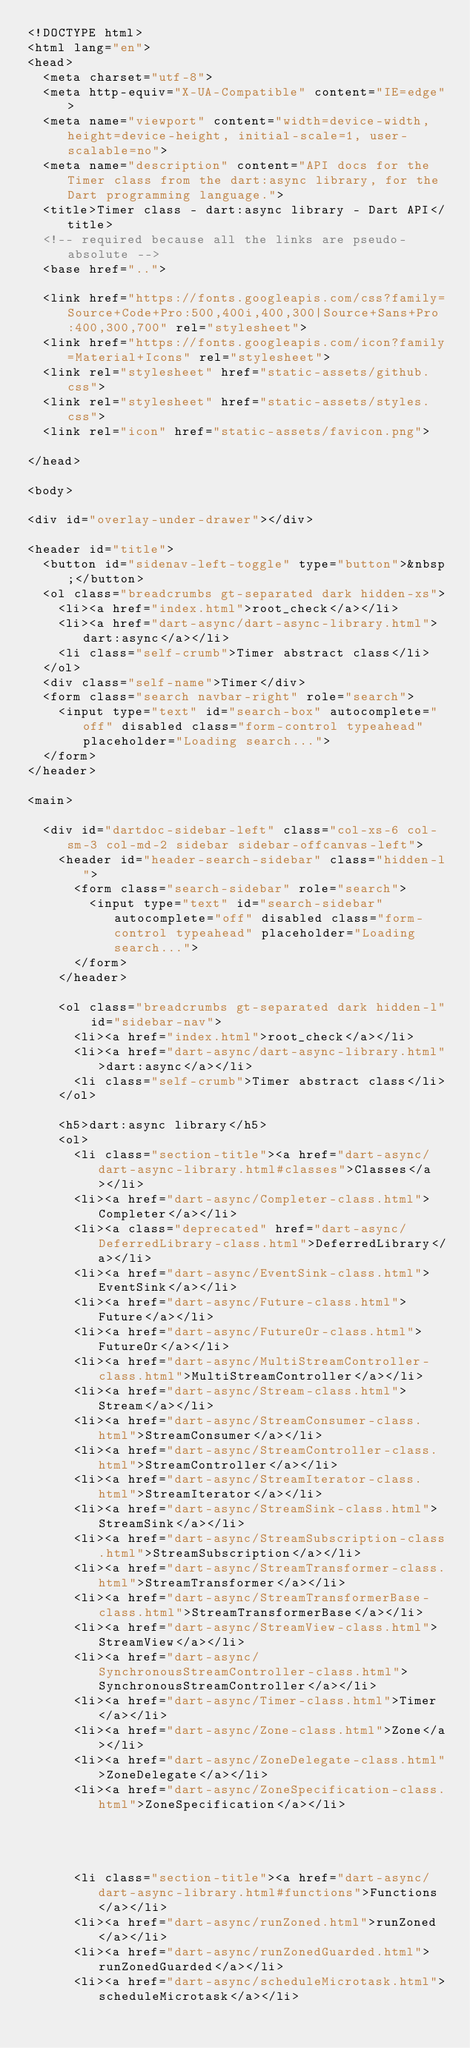<code> <loc_0><loc_0><loc_500><loc_500><_HTML_><!DOCTYPE html>
<html lang="en">
<head>
  <meta charset="utf-8">
  <meta http-equiv="X-UA-Compatible" content="IE=edge">
  <meta name="viewport" content="width=device-width, height=device-height, initial-scale=1, user-scalable=no">
  <meta name="description" content="API docs for the Timer class from the dart:async library, for the Dart programming language.">
  <title>Timer class - dart:async library - Dart API</title>
  <!-- required because all the links are pseudo-absolute -->
  <base href="..">

  <link href="https://fonts.googleapis.com/css?family=Source+Code+Pro:500,400i,400,300|Source+Sans+Pro:400,300,700" rel="stylesheet">
  <link href="https://fonts.googleapis.com/icon?family=Material+Icons" rel="stylesheet">
  <link rel="stylesheet" href="static-assets/github.css">
  <link rel="stylesheet" href="static-assets/styles.css">
  <link rel="icon" href="static-assets/favicon.png">
  
</head>

<body>

<div id="overlay-under-drawer"></div>

<header id="title">
  <button id="sidenav-left-toggle" type="button">&nbsp;</button>
  <ol class="breadcrumbs gt-separated dark hidden-xs">
    <li><a href="index.html">root_check</a></li>
    <li><a href="dart-async/dart-async-library.html">dart:async</a></li>
    <li class="self-crumb">Timer abstract class</li>
  </ol>
  <div class="self-name">Timer</div>
  <form class="search navbar-right" role="search">
    <input type="text" id="search-box" autocomplete="off" disabled class="form-control typeahead" placeholder="Loading search...">
  </form>
</header>

<main>

  <div id="dartdoc-sidebar-left" class="col-xs-6 col-sm-3 col-md-2 sidebar sidebar-offcanvas-left">
    <header id="header-search-sidebar" class="hidden-l">
      <form class="search-sidebar" role="search">
        <input type="text" id="search-sidebar" autocomplete="off" disabled class="form-control typeahead" placeholder="Loading search...">
      </form>
    </header>
    
    <ol class="breadcrumbs gt-separated dark hidden-l" id="sidebar-nav">
      <li><a href="index.html">root_check</a></li>
      <li><a href="dart-async/dart-async-library.html">dart:async</a></li>
      <li class="self-crumb">Timer abstract class</li>
    </ol>
    
    <h5>dart:async library</h5>
    <ol>
      <li class="section-title"><a href="dart-async/dart-async-library.html#classes">Classes</a></li>
      <li><a href="dart-async/Completer-class.html">Completer</a></li>
      <li><a class="deprecated" href="dart-async/DeferredLibrary-class.html">DeferredLibrary</a></li>
      <li><a href="dart-async/EventSink-class.html">EventSink</a></li>
      <li><a href="dart-async/Future-class.html">Future</a></li>
      <li><a href="dart-async/FutureOr-class.html">FutureOr</a></li>
      <li><a href="dart-async/MultiStreamController-class.html">MultiStreamController</a></li>
      <li><a href="dart-async/Stream-class.html">Stream</a></li>
      <li><a href="dart-async/StreamConsumer-class.html">StreamConsumer</a></li>
      <li><a href="dart-async/StreamController-class.html">StreamController</a></li>
      <li><a href="dart-async/StreamIterator-class.html">StreamIterator</a></li>
      <li><a href="dart-async/StreamSink-class.html">StreamSink</a></li>
      <li><a href="dart-async/StreamSubscription-class.html">StreamSubscription</a></li>
      <li><a href="dart-async/StreamTransformer-class.html">StreamTransformer</a></li>
      <li><a href="dart-async/StreamTransformerBase-class.html">StreamTransformerBase</a></li>
      <li><a href="dart-async/StreamView-class.html">StreamView</a></li>
      <li><a href="dart-async/SynchronousStreamController-class.html">SynchronousStreamController</a></li>
      <li><a href="dart-async/Timer-class.html">Timer</a></li>
      <li><a href="dart-async/Zone-class.html">Zone</a></li>
      <li><a href="dart-async/ZoneDelegate-class.html">ZoneDelegate</a></li>
      <li><a href="dart-async/ZoneSpecification-class.html">ZoneSpecification</a></li>
    
    
    
    
      <li class="section-title"><a href="dart-async/dart-async-library.html#functions">Functions</a></li>
      <li><a href="dart-async/runZoned.html">runZoned</a></li>
      <li><a href="dart-async/runZonedGuarded.html">runZonedGuarded</a></li>
      <li><a href="dart-async/scheduleMicrotask.html">scheduleMicrotask</a></li>
    
    </code> 